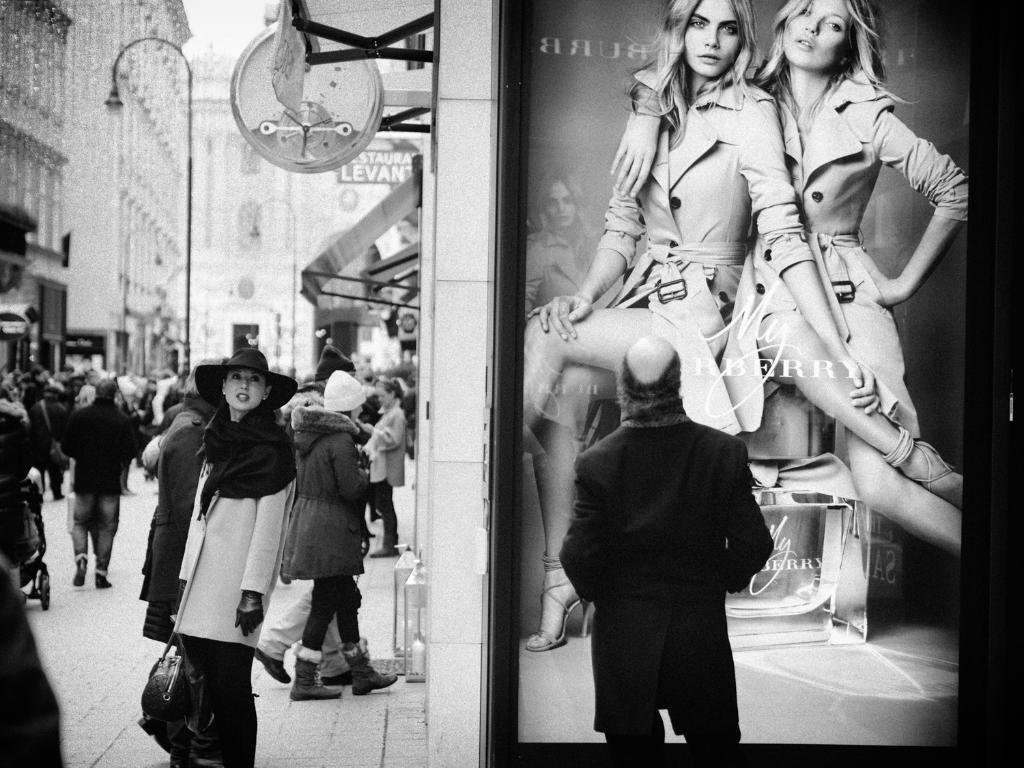Can you describe this image briefly? In this picture there is a person wearing black dress is standing in front of a picture there are few persons standing in the left corner and there are buildings in the background. 